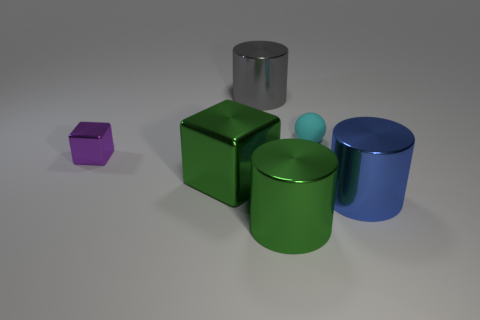Add 3 metal cylinders. How many objects exist? 9 Subtract all spheres. How many objects are left? 5 Subtract all tiny purple rubber blocks. Subtract all big things. How many objects are left? 2 Add 2 cylinders. How many cylinders are left? 5 Add 3 big gray cylinders. How many big gray cylinders exist? 4 Subtract 1 green cylinders. How many objects are left? 5 